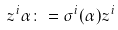<formula> <loc_0><loc_0><loc_500><loc_500>z ^ { i } \alpha \colon = \sigma ^ { i } ( \alpha ) z ^ { i }</formula> 